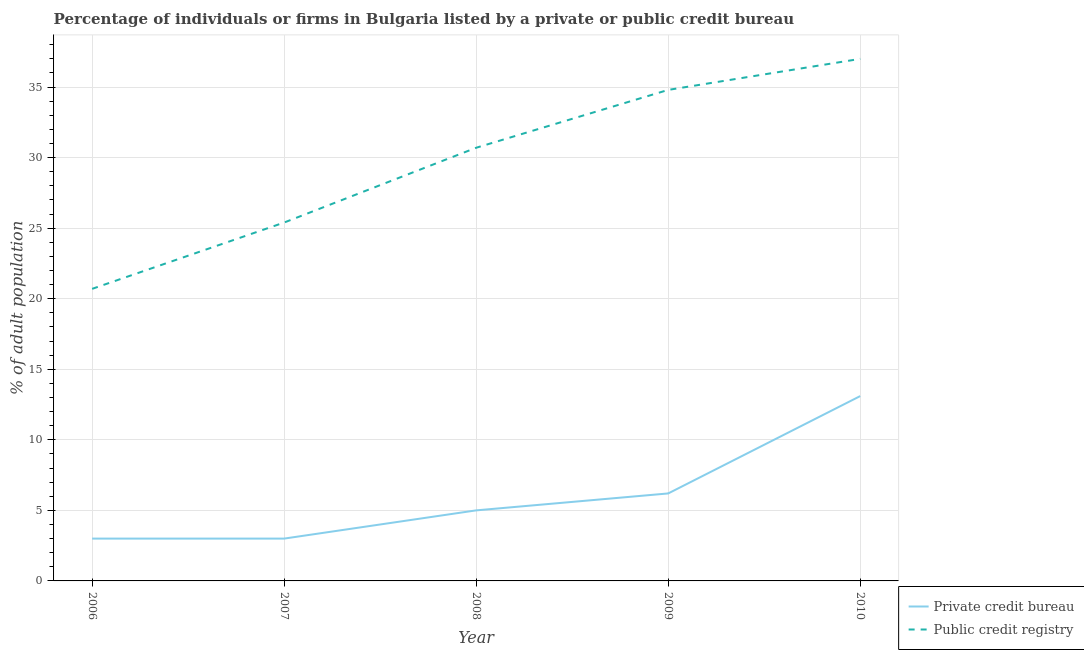How many different coloured lines are there?
Offer a very short reply. 2. What is the percentage of firms listed by public credit bureau in 2009?
Ensure brevity in your answer.  34.8. Across all years, what is the maximum percentage of firms listed by public credit bureau?
Provide a succinct answer. 37. Across all years, what is the minimum percentage of firms listed by public credit bureau?
Provide a short and direct response. 20.7. In which year was the percentage of firms listed by public credit bureau maximum?
Keep it short and to the point. 2010. What is the total percentage of firms listed by private credit bureau in the graph?
Give a very brief answer. 30.3. What is the difference between the percentage of firms listed by public credit bureau in 2006 and that in 2008?
Ensure brevity in your answer.  -10. What is the difference between the percentage of firms listed by public credit bureau in 2009 and the percentage of firms listed by private credit bureau in 2008?
Make the answer very short. 29.8. What is the average percentage of firms listed by public credit bureau per year?
Give a very brief answer. 29.72. In the year 2010, what is the difference between the percentage of firms listed by public credit bureau and percentage of firms listed by private credit bureau?
Your response must be concise. 23.9. What is the ratio of the percentage of firms listed by public credit bureau in 2006 to that in 2008?
Make the answer very short. 0.67. Is the percentage of firms listed by public credit bureau in 2008 less than that in 2010?
Your response must be concise. Yes. Is the difference between the percentage of firms listed by private credit bureau in 2008 and 2010 greater than the difference between the percentage of firms listed by public credit bureau in 2008 and 2010?
Keep it short and to the point. No. What is the difference between the highest and the second highest percentage of firms listed by public credit bureau?
Offer a terse response. 2.2. What is the difference between the highest and the lowest percentage of firms listed by private credit bureau?
Make the answer very short. 10.1. Is the sum of the percentage of firms listed by private credit bureau in 2006 and 2008 greater than the maximum percentage of firms listed by public credit bureau across all years?
Provide a succinct answer. No. Does the percentage of firms listed by public credit bureau monotonically increase over the years?
Offer a very short reply. Yes. How many lines are there?
Provide a succinct answer. 2. How many years are there in the graph?
Offer a terse response. 5. Are the values on the major ticks of Y-axis written in scientific E-notation?
Your response must be concise. No. Does the graph contain grids?
Give a very brief answer. Yes. Where does the legend appear in the graph?
Your answer should be compact. Bottom right. How many legend labels are there?
Your answer should be very brief. 2. How are the legend labels stacked?
Keep it short and to the point. Vertical. What is the title of the graph?
Make the answer very short. Percentage of individuals or firms in Bulgaria listed by a private or public credit bureau. What is the label or title of the Y-axis?
Offer a terse response. % of adult population. What is the % of adult population of Public credit registry in 2006?
Your answer should be compact. 20.7. What is the % of adult population of Private credit bureau in 2007?
Your response must be concise. 3. What is the % of adult population in Public credit registry in 2007?
Provide a short and direct response. 25.4. What is the % of adult population in Public credit registry in 2008?
Give a very brief answer. 30.7. What is the % of adult population of Private credit bureau in 2009?
Offer a very short reply. 6.2. What is the % of adult population in Public credit registry in 2009?
Keep it short and to the point. 34.8. What is the % of adult population of Private credit bureau in 2010?
Offer a terse response. 13.1. Across all years, what is the maximum % of adult population in Public credit registry?
Your answer should be compact. 37. Across all years, what is the minimum % of adult population in Public credit registry?
Offer a terse response. 20.7. What is the total % of adult population of Private credit bureau in the graph?
Your response must be concise. 30.3. What is the total % of adult population in Public credit registry in the graph?
Ensure brevity in your answer.  148.6. What is the difference between the % of adult population in Private credit bureau in 2006 and that in 2007?
Your answer should be compact. 0. What is the difference between the % of adult population in Public credit registry in 2006 and that in 2007?
Give a very brief answer. -4.7. What is the difference between the % of adult population of Private credit bureau in 2006 and that in 2008?
Offer a very short reply. -2. What is the difference between the % of adult population of Private credit bureau in 2006 and that in 2009?
Give a very brief answer. -3.2. What is the difference between the % of adult population of Public credit registry in 2006 and that in 2009?
Provide a short and direct response. -14.1. What is the difference between the % of adult population of Private credit bureau in 2006 and that in 2010?
Make the answer very short. -10.1. What is the difference between the % of adult population in Public credit registry in 2006 and that in 2010?
Your answer should be compact. -16.3. What is the difference between the % of adult population of Private credit bureau in 2007 and that in 2008?
Your response must be concise. -2. What is the difference between the % of adult population in Public credit registry in 2007 and that in 2008?
Your answer should be very brief. -5.3. What is the difference between the % of adult population in Public credit registry in 2007 and that in 2009?
Provide a succinct answer. -9.4. What is the difference between the % of adult population of Public credit registry in 2007 and that in 2010?
Your response must be concise. -11.6. What is the difference between the % of adult population in Private credit bureau in 2008 and that in 2009?
Provide a succinct answer. -1.2. What is the difference between the % of adult population in Public credit registry in 2008 and that in 2009?
Provide a succinct answer. -4.1. What is the difference between the % of adult population of Private credit bureau in 2008 and that in 2010?
Provide a succinct answer. -8.1. What is the difference between the % of adult population of Private credit bureau in 2006 and the % of adult population of Public credit registry in 2007?
Offer a terse response. -22.4. What is the difference between the % of adult population of Private credit bureau in 2006 and the % of adult population of Public credit registry in 2008?
Provide a succinct answer. -27.7. What is the difference between the % of adult population of Private credit bureau in 2006 and the % of adult population of Public credit registry in 2009?
Offer a very short reply. -31.8. What is the difference between the % of adult population of Private credit bureau in 2006 and the % of adult population of Public credit registry in 2010?
Your response must be concise. -34. What is the difference between the % of adult population in Private credit bureau in 2007 and the % of adult population in Public credit registry in 2008?
Your answer should be compact. -27.7. What is the difference between the % of adult population of Private credit bureau in 2007 and the % of adult population of Public credit registry in 2009?
Keep it short and to the point. -31.8. What is the difference between the % of adult population of Private credit bureau in 2007 and the % of adult population of Public credit registry in 2010?
Your response must be concise. -34. What is the difference between the % of adult population in Private credit bureau in 2008 and the % of adult population in Public credit registry in 2009?
Your response must be concise. -29.8. What is the difference between the % of adult population of Private credit bureau in 2008 and the % of adult population of Public credit registry in 2010?
Make the answer very short. -32. What is the difference between the % of adult population of Private credit bureau in 2009 and the % of adult population of Public credit registry in 2010?
Offer a terse response. -30.8. What is the average % of adult population in Private credit bureau per year?
Offer a terse response. 6.06. What is the average % of adult population in Public credit registry per year?
Your answer should be compact. 29.72. In the year 2006, what is the difference between the % of adult population in Private credit bureau and % of adult population in Public credit registry?
Your answer should be compact. -17.7. In the year 2007, what is the difference between the % of adult population of Private credit bureau and % of adult population of Public credit registry?
Keep it short and to the point. -22.4. In the year 2008, what is the difference between the % of adult population in Private credit bureau and % of adult population in Public credit registry?
Your answer should be very brief. -25.7. In the year 2009, what is the difference between the % of adult population in Private credit bureau and % of adult population in Public credit registry?
Your response must be concise. -28.6. In the year 2010, what is the difference between the % of adult population of Private credit bureau and % of adult population of Public credit registry?
Your answer should be compact. -23.9. What is the ratio of the % of adult population of Private credit bureau in 2006 to that in 2007?
Your answer should be compact. 1. What is the ratio of the % of adult population in Public credit registry in 2006 to that in 2007?
Keep it short and to the point. 0.81. What is the ratio of the % of adult population in Public credit registry in 2006 to that in 2008?
Your response must be concise. 0.67. What is the ratio of the % of adult population of Private credit bureau in 2006 to that in 2009?
Your answer should be very brief. 0.48. What is the ratio of the % of adult population of Public credit registry in 2006 to that in 2009?
Give a very brief answer. 0.59. What is the ratio of the % of adult population of Private credit bureau in 2006 to that in 2010?
Keep it short and to the point. 0.23. What is the ratio of the % of adult population of Public credit registry in 2006 to that in 2010?
Make the answer very short. 0.56. What is the ratio of the % of adult population in Private credit bureau in 2007 to that in 2008?
Provide a short and direct response. 0.6. What is the ratio of the % of adult population of Public credit registry in 2007 to that in 2008?
Your response must be concise. 0.83. What is the ratio of the % of adult population in Private credit bureau in 2007 to that in 2009?
Your answer should be compact. 0.48. What is the ratio of the % of adult population of Public credit registry in 2007 to that in 2009?
Make the answer very short. 0.73. What is the ratio of the % of adult population of Private credit bureau in 2007 to that in 2010?
Provide a short and direct response. 0.23. What is the ratio of the % of adult population in Public credit registry in 2007 to that in 2010?
Your answer should be compact. 0.69. What is the ratio of the % of adult population of Private credit bureau in 2008 to that in 2009?
Your answer should be compact. 0.81. What is the ratio of the % of adult population of Public credit registry in 2008 to that in 2009?
Your answer should be very brief. 0.88. What is the ratio of the % of adult population in Private credit bureau in 2008 to that in 2010?
Your answer should be very brief. 0.38. What is the ratio of the % of adult population in Public credit registry in 2008 to that in 2010?
Provide a short and direct response. 0.83. What is the ratio of the % of adult population in Private credit bureau in 2009 to that in 2010?
Ensure brevity in your answer.  0.47. What is the ratio of the % of adult population in Public credit registry in 2009 to that in 2010?
Ensure brevity in your answer.  0.94. What is the difference between the highest and the second highest % of adult population in Private credit bureau?
Keep it short and to the point. 6.9. What is the difference between the highest and the lowest % of adult population in Public credit registry?
Your response must be concise. 16.3. 